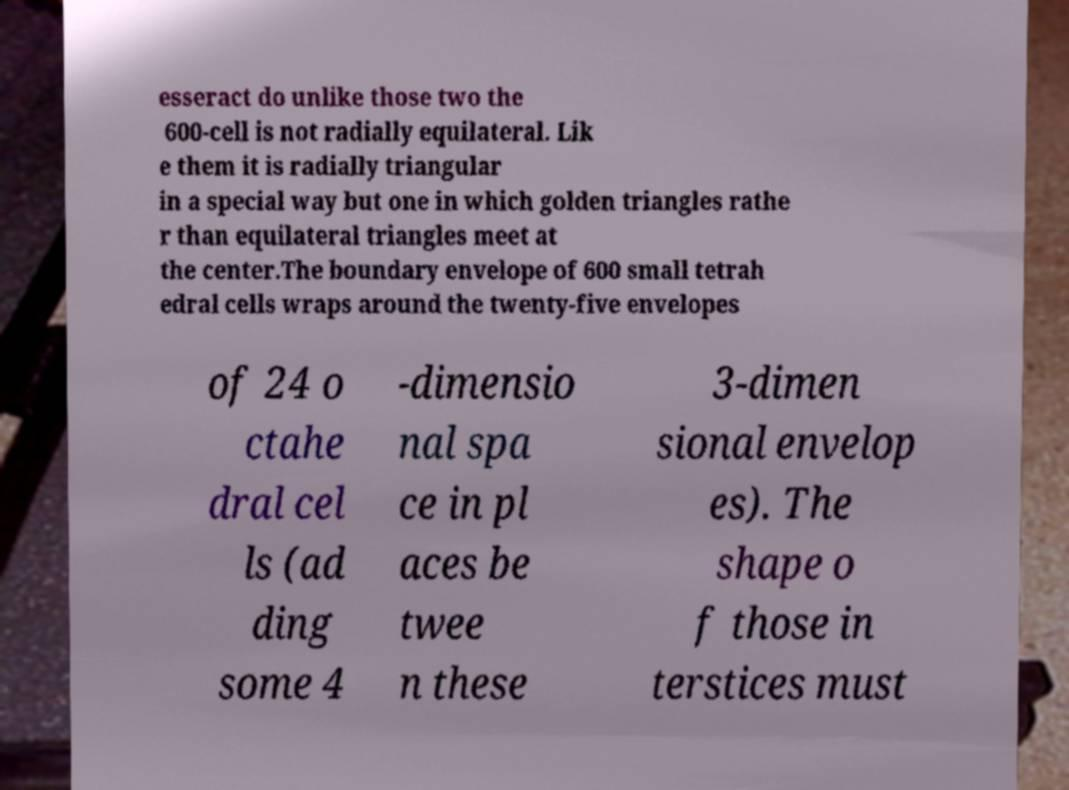Can you read and provide the text displayed in the image?This photo seems to have some interesting text. Can you extract and type it out for me? esseract do unlike those two the 600-cell is not radially equilateral. Lik e them it is radially triangular in a special way but one in which golden triangles rathe r than equilateral triangles meet at the center.The boundary envelope of 600 small tetrah edral cells wraps around the twenty-five envelopes of 24 o ctahe dral cel ls (ad ding some 4 -dimensio nal spa ce in pl aces be twee n these 3-dimen sional envelop es). The shape o f those in terstices must 